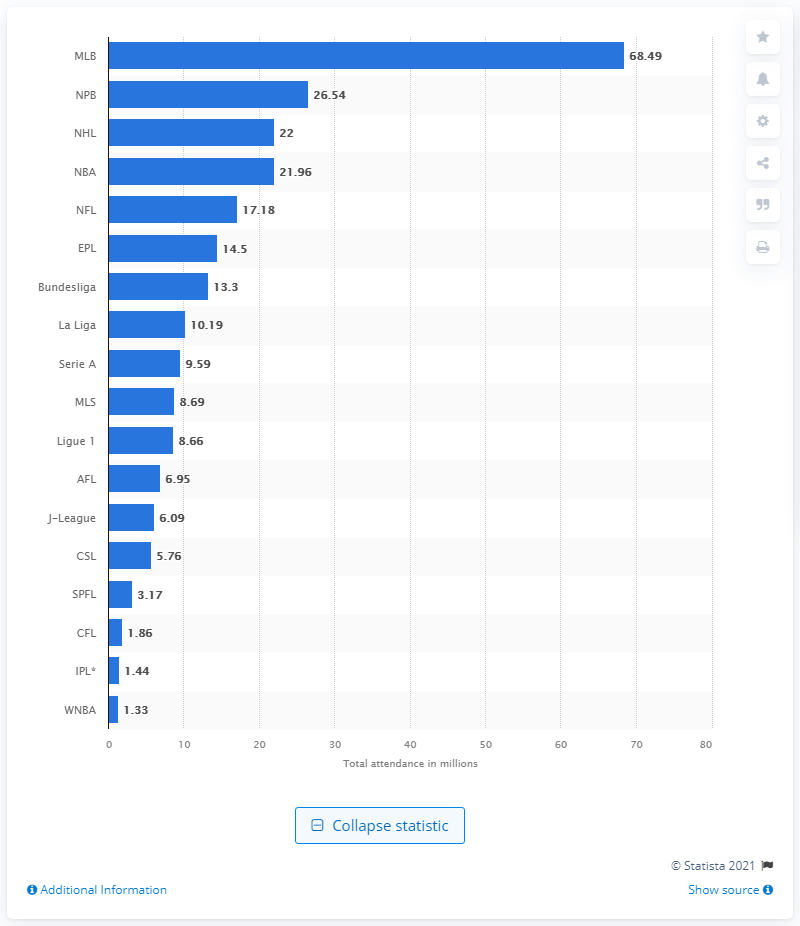Give some essential details in this illustration. In 2019, it is estimated that 68.49 people watched Major League Baseball (MLB) games live. 